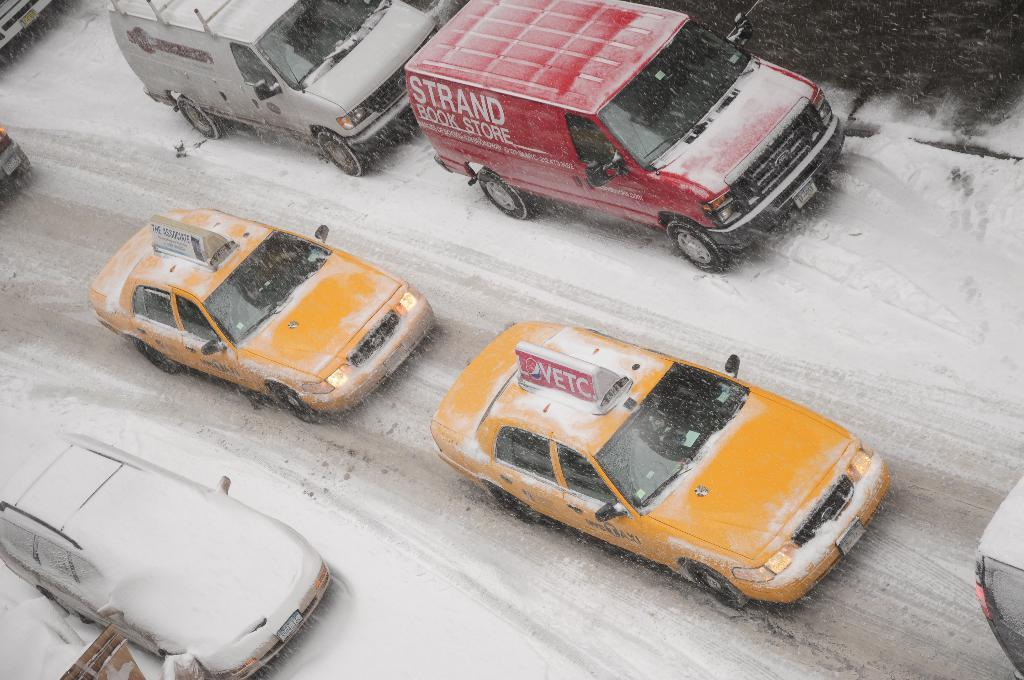<image>
Present a compact description of the photo's key features. Two trucks, one red and bearing the words Strand Bookstore are travelling through the snow next to two yellow taxis one of which bears advertising for Avtec. 